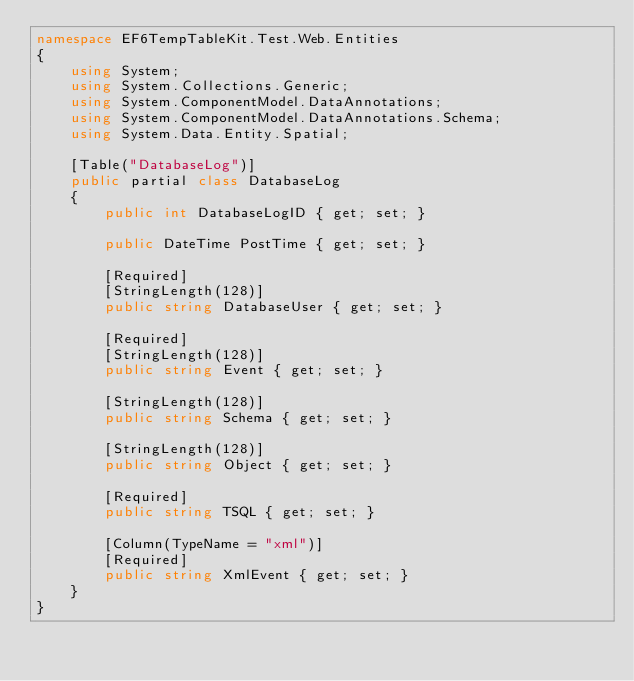Convert code to text. <code><loc_0><loc_0><loc_500><loc_500><_C#_>namespace EF6TempTableKit.Test.Web.Entities
{
    using System;
    using System.Collections.Generic;
    using System.ComponentModel.DataAnnotations;
    using System.ComponentModel.DataAnnotations.Schema;
    using System.Data.Entity.Spatial;

    [Table("DatabaseLog")]
    public partial class DatabaseLog
    {
        public int DatabaseLogID { get; set; }

        public DateTime PostTime { get; set; }

        [Required]
        [StringLength(128)]
        public string DatabaseUser { get; set; }

        [Required]
        [StringLength(128)]
        public string Event { get; set; }

        [StringLength(128)]
        public string Schema { get; set; }

        [StringLength(128)]
        public string Object { get; set; }

        [Required]
        public string TSQL { get; set; }

        [Column(TypeName = "xml")]
        [Required]
        public string XmlEvent { get; set; }
    }
}
</code> 